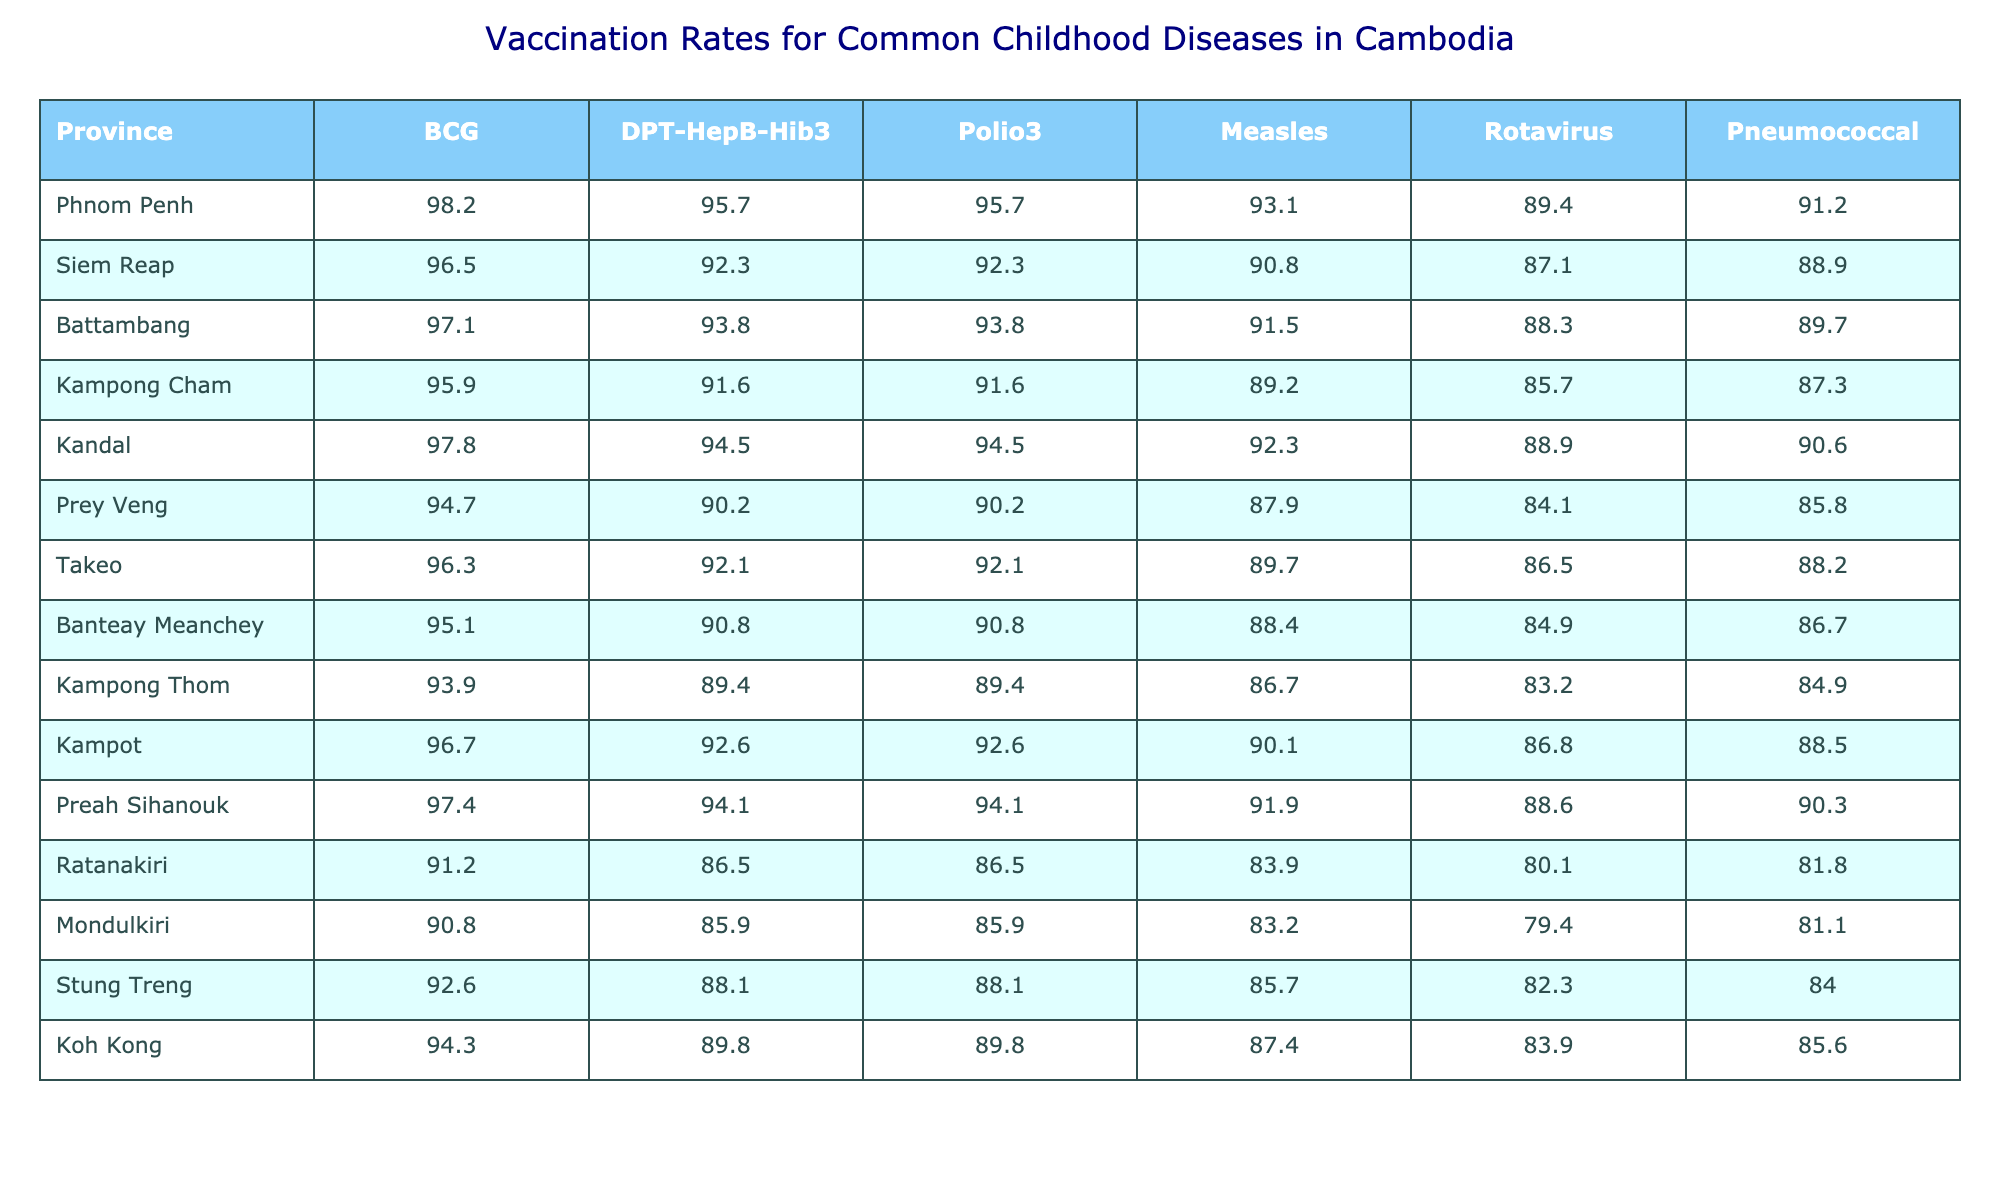What is the vaccination rate for Measles in Phnom Penh? According to the table, the vaccination rate for Measles in Phnom Penh is listed directly under the Measles column for that province. It shows a value of 93.1.
Answer: 93.1 Which province has the highest DPT-HepB-Hib3 vaccination rate? By looking at the DPT-HepB-Hib3 column, we can compare the vaccination rates of all provinces. Phnom Penh has the highest rate at 95.7.
Answer: Phnom Penh What is the difference in Pneumococcal vaccination rates between Kandal and Ratanakiri? First, find the Pneumococcal rates: Kandal is 90.6 and Ratanakiri is 81.8. Now calculate the difference: 90.6 - 81.8 = 8.8.
Answer: 8.8 What is the average vaccination rate for Rotavirus across all provinces? To find the average for Rotavirus, sum all the rates: 89.4 + 87.1 + 88.3 + 85.7 + 88.9 + 84.1 + 86.5 + 84.9 + 83.2 + 86.8 + 88.6 + 80.1 + 79.4 + 82.3 + 83.9 = 1,297. Now divide by the number of provinces (15): 1,297 / 15 = approximately 86.5.
Answer: 86.5 Is the vaccination rate for BCG lower in Prey Veng compared to Kampong Cham? Prey Veng has a BCG rate of 94.7 and Kampong Cham has 95.9. Since 94.7 is less than 95.9, the statement is true.
Answer: Yes Which provinces have a Polio3 vaccination rate lower than 90%? Look at the Polio3 column and find any rates below 90%. Ratanakiri (86.5) and Mondulkiri (85.9) both have vaccination rates lower than 90%.
Answer: Ratanakiri and Mondulkiri What province has the second lowest vaccination rate for DPT-HepB-Hib3? We review the DPT-HepB-Hib3 column and identify the rates: Ratanakiri (86.5), Mondulkiri (85.9), Kampong Thom (89.4), and so on. The second lowest is Kampong Thom at 89.4.
Answer: Kampong Thom What percentage of provinces have a Measles vaccination rate above 90%? Count the provinces with rates above 90%: Phnom Penh, Siem Reap, Battambang, Kandal, Takeo, Preah Sihanouk. That’s 6 provinces out of 15. Now calculate the percentage: (6/15)*100 = 40%.
Answer: 40% Which province has the lowest overall vaccination rates across all diseases? To find the lowest overall vaccination rates, we'll check each province's lowest recorded vaccination value. Ratanakiri's lowest rate is 80.1 for Pneumococcal, which is the lowest compared to all provinces.
Answer: Ratanakiri Are there any provinces with vaccination rates of exactly 97.4? Scanning through the table, we find that the vaccination rate of 97.4 is present only for Preah Sihanouk. Hence, there is one province with this rate.
Answer: Yes 